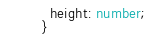<code> <loc_0><loc_0><loc_500><loc_500><_TypeScript_>  height: number;
}
</code> 